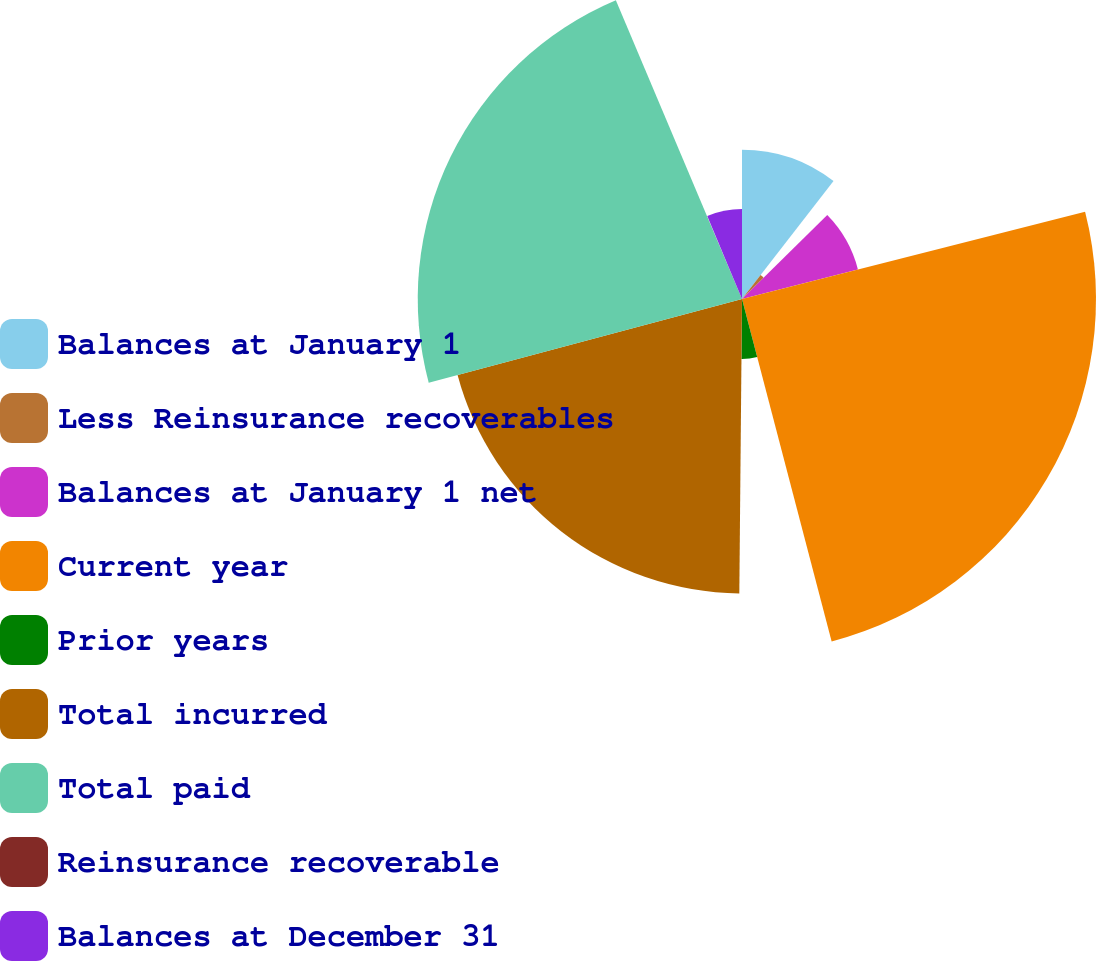Convert chart. <chart><loc_0><loc_0><loc_500><loc_500><pie_chart><fcel>Balances at January 1<fcel>Less Reinsurance recoverables<fcel>Balances at January 1 net<fcel>Current year<fcel>Prior years<fcel>Total incurred<fcel>Total paid<fcel>Reinsurance recoverable<fcel>Balances at December 31<nl><fcel>10.5%<fcel>2.13%<fcel>8.41%<fcel>24.89%<fcel>4.22%<fcel>20.7%<fcel>22.8%<fcel>0.04%<fcel>6.32%<nl></chart> 